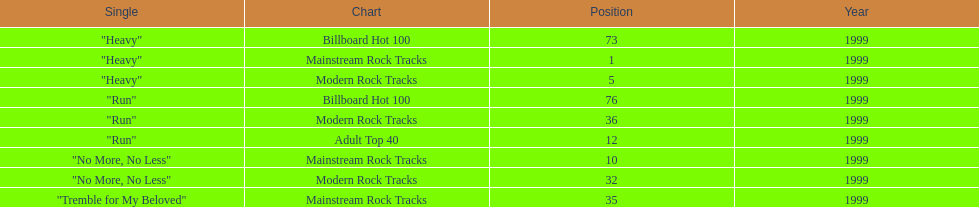How many singles from "dosage" appeared on the modern rock tracks charts? 3. 